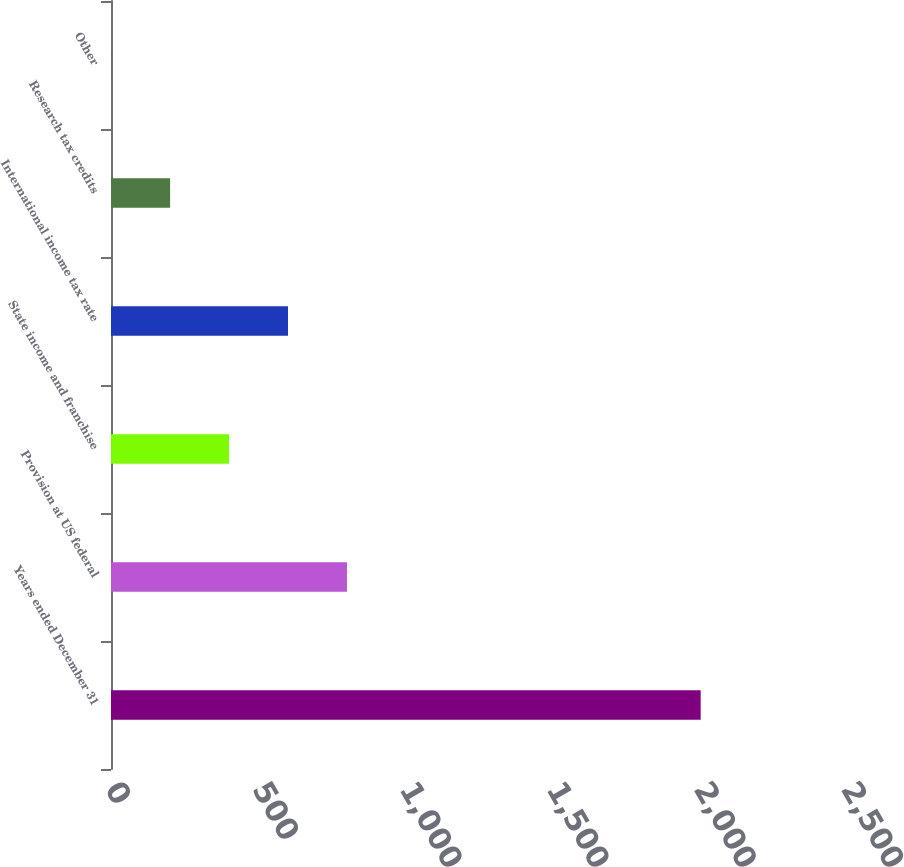<chart> <loc_0><loc_0><loc_500><loc_500><bar_chart><fcel>Years ended December 31<fcel>Provision at US federal<fcel>State income and franchise<fcel>International income tax rate<fcel>Research tax credits<fcel>Other<nl><fcel>2003<fcel>801.5<fcel>401<fcel>601.25<fcel>200.75<fcel>0.5<nl></chart> 